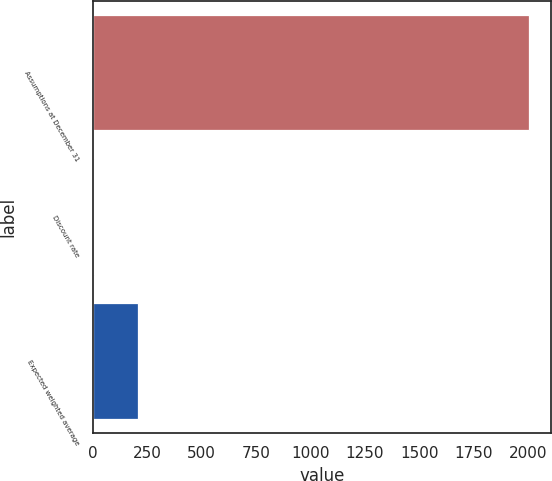<chart> <loc_0><loc_0><loc_500><loc_500><bar_chart><fcel>Assumptions at December 31<fcel>Discount rate<fcel>Expected weighted average<nl><fcel>2004<fcel>6<fcel>205.8<nl></chart> 